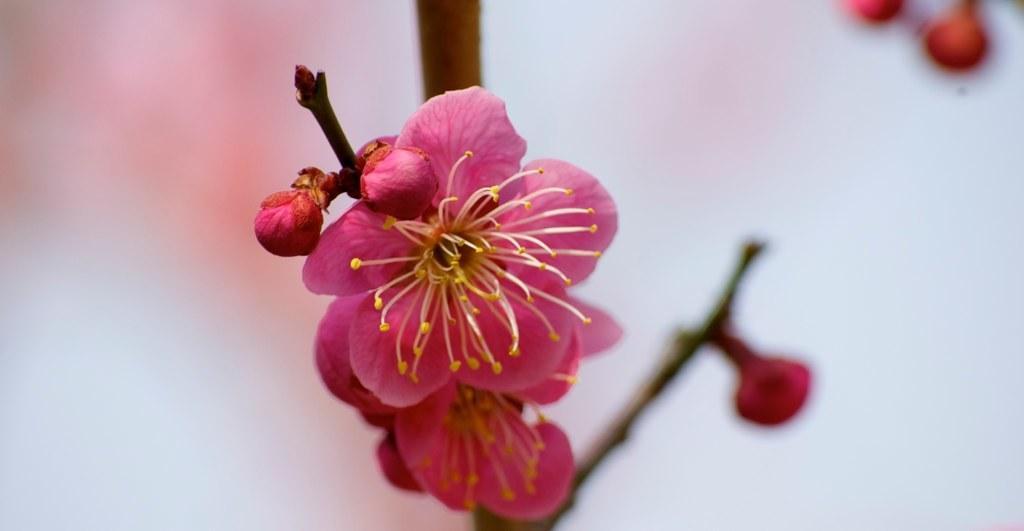Can you describe this image briefly? In this image there are flowers and buds to the stem. The background is blurry. 